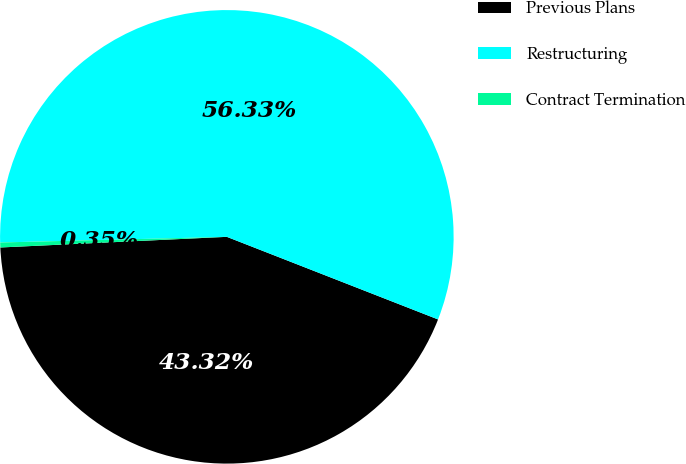Convert chart. <chart><loc_0><loc_0><loc_500><loc_500><pie_chart><fcel>Previous Plans<fcel>Restructuring<fcel>Contract Termination<nl><fcel>43.32%<fcel>56.33%<fcel>0.35%<nl></chart> 